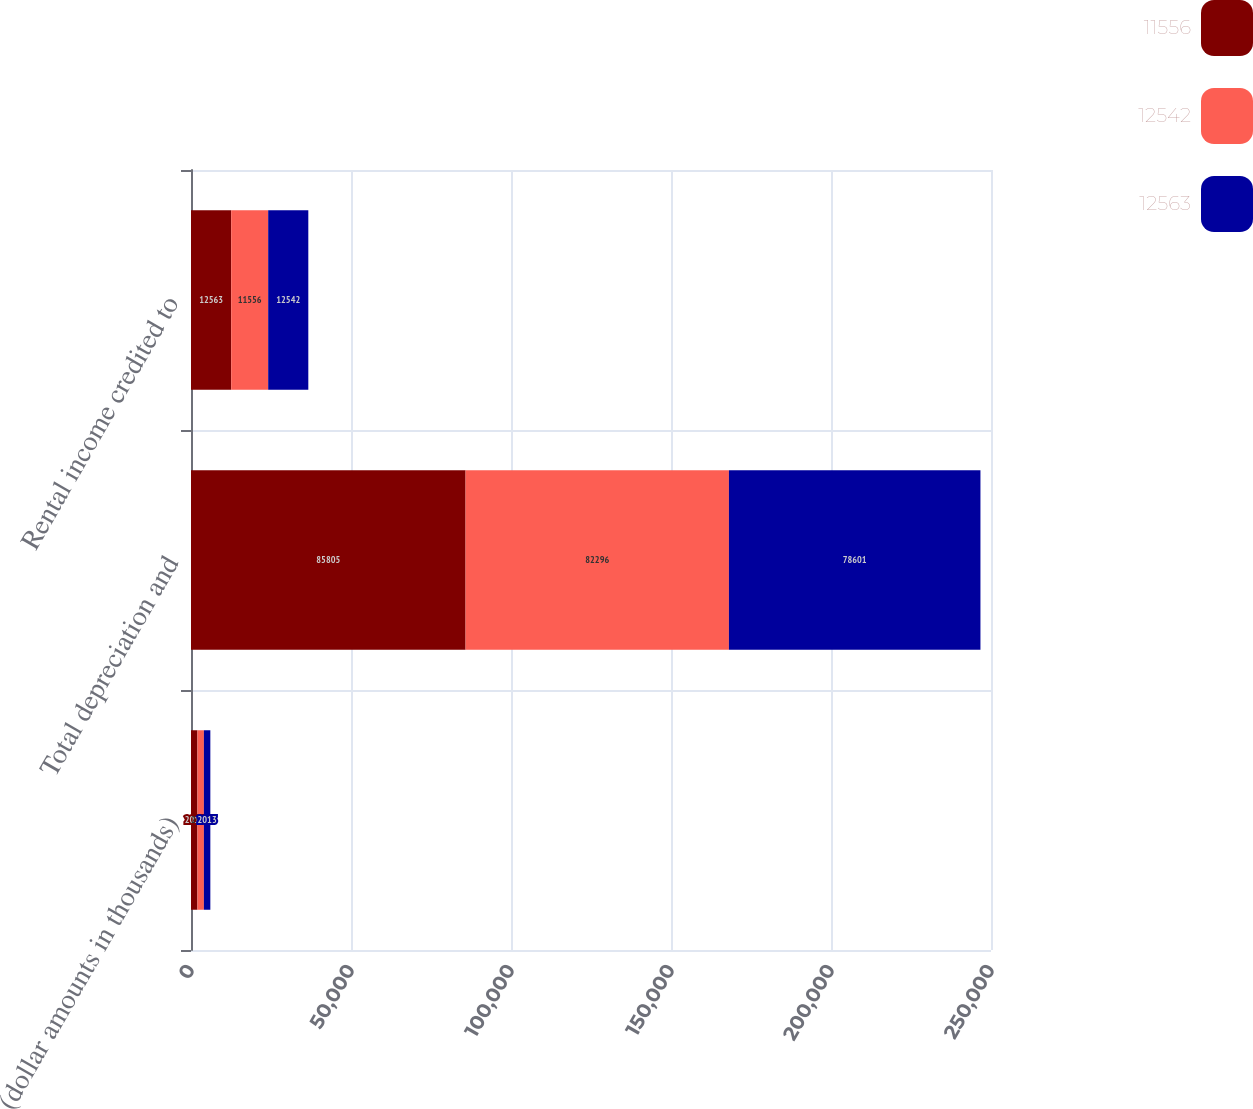Convert chart. <chart><loc_0><loc_0><loc_500><loc_500><stacked_bar_chart><ecel><fcel>(dollar amounts in thousands)<fcel>Total depreciation and<fcel>Rental income credited to<nl><fcel>11556<fcel>2015<fcel>85805<fcel>12563<nl><fcel>12542<fcel>2014<fcel>82296<fcel>11556<nl><fcel>12563<fcel>2013<fcel>78601<fcel>12542<nl></chart> 